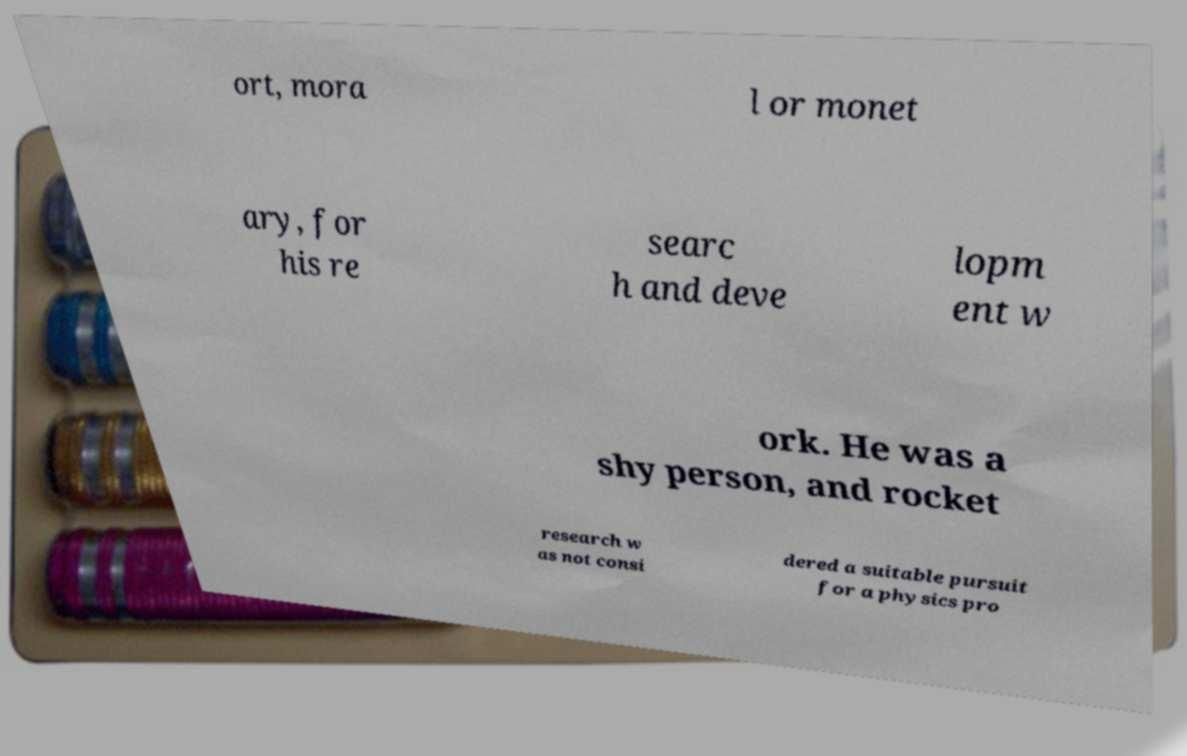Can you read and provide the text displayed in the image?This photo seems to have some interesting text. Can you extract and type it out for me? ort, mora l or monet ary, for his re searc h and deve lopm ent w ork. He was a shy person, and rocket research w as not consi dered a suitable pursuit for a physics pro 